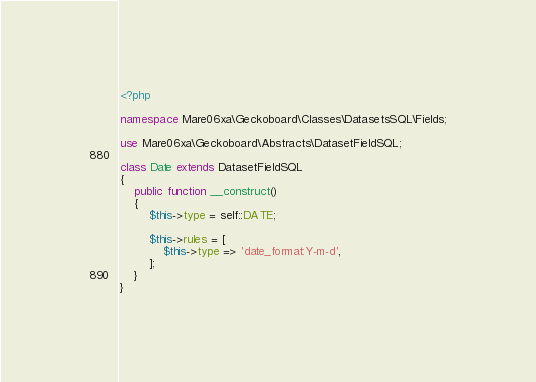<code> <loc_0><loc_0><loc_500><loc_500><_PHP_><?php

namespace Mare06xa\Geckoboard\Classes\DatasetsSQL\Fields;

use Mare06xa\Geckoboard\Abstracts\DatasetFieldSQL;

class Date extends DatasetFieldSQL
{
    public function __construct()
    {
        $this->type = self::DATE;

        $this->rules = [
            $this->type => 'date_format:Y-m-d',
        ];
    }
}
</code> 